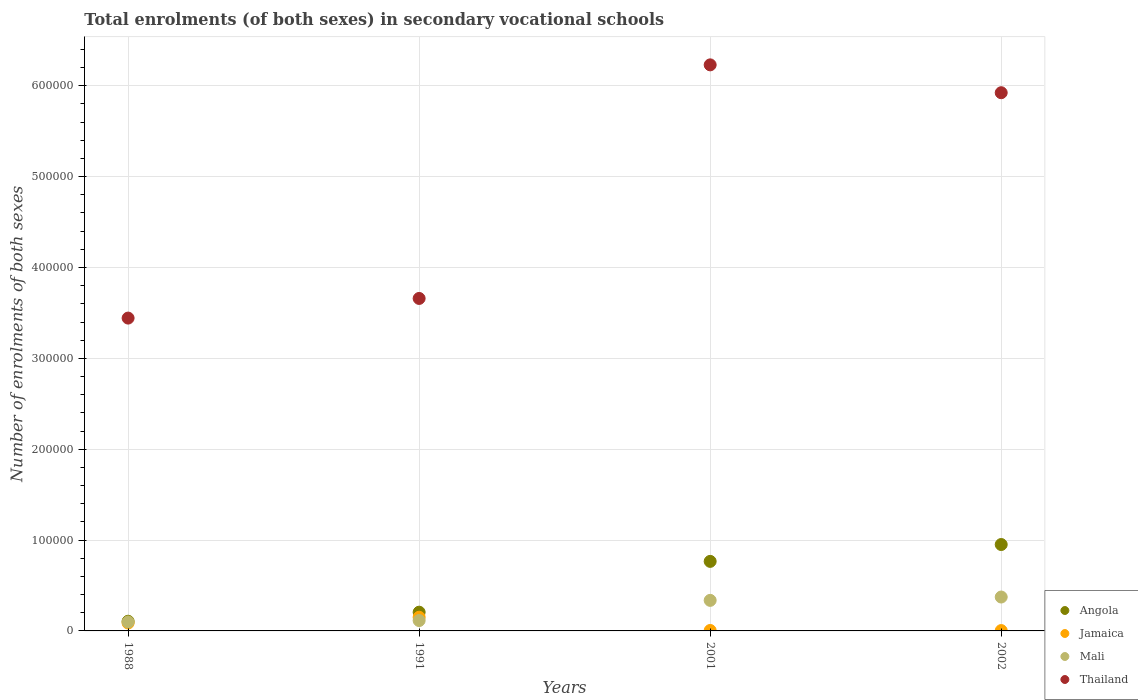How many different coloured dotlines are there?
Make the answer very short. 4. Is the number of dotlines equal to the number of legend labels?
Your response must be concise. Yes. What is the number of enrolments in secondary schools in Jamaica in 2002?
Your answer should be compact. 382. Across all years, what is the maximum number of enrolments in secondary schools in Mali?
Ensure brevity in your answer.  3.73e+04. Across all years, what is the minimum number of enrolments in secondary schools in Angola?
Give a very brief answer. 1.07e+04. In which year was the number of enrolments in secondary schools in Angola minimum?
Provide a succinct answer. 1988. What is the total number of enrolments in secondary schools in Jamaica in the graph?
Your response must be concise. 2.47e+04. What is the difference between the number of enrolments in secondary schools in Angola in 1988 and that in 2002?
Make the answer very short. -8.44e+04. What is the difference between the number of enrolments in secondary schools in Thailand in 1988 and the number of enrolments in secondary schools in Jamaica in 2001?
Give a very brief answer. 3.44e+05. What is the average number of enrolments in secondary schools in Mali per year?
Offer a very short reply. 2.30e+04. In the year 2001, what is the difference between the number of enrolments in secondary schools in Angola and number of enrolments in secondary schools in Thailand?
Keep it short and to the point. -5.46e+05. In how many years, is the number of enrolments in secondary schools in Angola greater than 120000?
Your answer should be very brief. 0. What is the ratio of the number of enrolments in secondary schools in Angola in 2001 to that in 2002?
Give a very brief answer. 0.8. What is the difference between the highest and the second highest number of enrolments in secondary schools in Thailand?
Give a very brief answer. 3.07e+04. What is the difference between the highest and the lowest number of enrolments in secondary schools in Thailand?
Give a very brief answer. 2.79e+05. Is the sum of the number of enrolments in secondary schools in Angola in 1991 and 2002 greater than the maximum number of enrolments in secondary schools in Mali across all years?
Your answer should be compact. Yes. Is it the case that in every year, the sum of the number of enrolments in secondary schools in Mali and number of enrolments in secondary schools in Angola  is greater than the sum of number of enrolments in secondary schools in Thailand and number of enrolments in secondary schools in Jamaica?
Your answer should be compact. No. Is the number of enrolments in secondary schools in Jamaica strictly less than the number of enrolments in secondary schools in Mali over the years?
Provide a succinct answer. No. How many dotlines are there?
Offer a terse response. 4. Are the values on the major ticks of Y-axis written in scientific E-notation?
Ensure brevity in your answer.  No. Does the graph contain any zero values?
Ensure brevity in your answer.  No. Does the graph contain grids?
Provide a succinct answer. Yes. How many legend labels are there?
Your answer should be compact. 4. How are the legend labels stacked?
Offer a very short reply. Vertical. What is the title of the graph?
Keep it short and to the point. Total enrolments (of both sexes) in secondary vocational schools. What is the label or title of the Y-axis?
Make the answer very short. Number of enrolments of both sexes. What is the Number of enrolments of both sexes of Angola in 1988?
Your response must be concise. 1.07e+04. What is the Number of enrolments of both sexes of Jamaica in 1988?
Keep it short and to the point. 8717. What is the Number of enrolments of both sexes in Mali in 1988?
Your response must be concise. 9813. What is the Number of enrolments of both sexes of Thailand in 1988?
Keep it short and to the point. 3.44e+05. What is the Number of enrolments of both sexes in Angola in 1991?
Ensure brevity in your answer.  2.06e+04. What is the Number of enrolments of both sexes of Jamaica in 1991?
Ensure brevity in your answer.  1.51e+04. What is the Number of enrolments of both sexes of Mali in 1991?
Provide a succinct answer. 1.14e+04. What is the Number of enrolments of both sexes of Thailand in 1991?
Make the answer very short. 3.66e+05. What is the Number of enrolments of both sexes in Angola in 2001?
Keep it short and to the point. 7.65e+04. What is the Number of enrolments of both sexes in Jamaica in 2001?
Ensure brevity in your answer.  498. What is the Number of enrolments of both sexes in Mali in 2001?
Offer a very short reply. 3.36e+04. What is the Number of enrolments of both sexes of Thailand in 2001?
Your answer should be very brief. 6.23e+05. What is the Number of enrolments of both sexes in Angola in 2002?
Offer a terse response. 9.51e+04. What is the Number of enrolments of both sexes of Jamaica in 2002?
Ensure brevity in your answer.  382. What is the Number of enrolments of both sexes in Mali in 2002?
Provide a succinct answer. 3.73e+04. What is the Number of enrolments of both sexes in Thailand in 2002?
Offer a terse response. 5.92e+05. Across all years, what is the maximum Number of enrolments of both sexes in Angola?
Offer a terse response. 9.51e+04. Across all years, what is the maximum Number of enrolments of both sexes in Jamaica?
Ensure brevity in your answer.  1.51e+04. Across all years, what is the maximum Number of enrolments of both sexes in Mali?
Provide a succinct answer. 3.73e+04. Across all years, what is the maximum Number of enrolments of both sexes of Thailand?
Offer a terse response. 6.23e+05. Across all years, what is the minimum Number of enrolments of both sexes of Angola?
Offer a very short reply. 1.07e+04. Across all years, what is the minimum Number of enrolments of both sexes in Jamaica?
Your response must be concise. 382. Across all years, what is the minimum Number of enrolments of both sexes in Mali?
Give a very brief answer. 9813. Across all years, what is the minimum Number of enrolments of both sexes in Thailand?
Keep it short and to the point. 3.44e+05. What is the total Number of enrolments of both sexes of Angola in the graph?
Offer a terse response. 2.03e+05. What is the total Number of enrolments of both sexes in Jamaica in the graph?
Provide a short and direct response. 2.47e+04. What is the total Number of enrolments of both sexes of Mali in the graph?
Provide a short and direct response. 9.22e+04. What is the total Number of enrolments of both sexes of Thailand in the graph?
Your response must be concise. 1.93e+06. What is the difference between the Number of enrolments of both sexes of Angola in 1988 and that in 1991?
Your answer should be compact. -9962. What is the difference between the Number of enrolments of both sexes in Jamaica in 1988 and that in 1991?
Keep it short and to the point. -6353. What is the difference between the Number of enrolments of both sexes in Mali in 1988 and that in 1991?
Your response must be concise. -1619. What is the difference between the Number of enrolments of both sexes in Thailand in 1988 and that in 1991?
Make the answer very short. -2.16e+04. What is the difference between the Number of enrolments of both sexes in Angola in 1988 and that in 2001?
Provide a short and direct response. -6.59e+04. What is the difference between the Number of enrolments of both sexes in Jamaica in 1988 and that in 2001?
Make the answer very short. 8219. What is the difference between the Number of enrolments of both sexes in Mali in 1988 and that in 2001?
Your answer should be very brief. -2.38e+04. What is the difference between the Number of enrolments of both sexes in Thailand in 1988 and that in 2001?
Provide a succinct answer. -2.79e+05. What is the difference between the Number of enrolments of both sexes in Angola in 1988 and that in 2002?
Ensure brevity in your answer.  -8.44e+04. What is the difference between the Number of enrolments of both sexes of Jamaica in 1988 and that in 2002?
Give a very brief answer. 8335. What is the difference between the Number of enrolments of both sexes in Mali in 1988 and that in 2002?
Offer a very short reply. -2.75e+04. What is the difference between the Number of enrolments of both sexes of Thailand in 1988 and that in 2002?
Keep it short and to the point. -2.48e+05. What is the difference between the Number of enrolments of both sexes of Angola in 1991 and that in 2001?
Provide a short and direct response. -5.59e+04. What is the difference between the Number of enrolments of both sexes in Jamaica in 1991 and that in 2001?
Ensure brevity in your answer.  1.46e+04. What is the difference between the Number of enrolments of both sexes in Mali in 1991 and that in 2001?
Ensure brevity in your answer.  -2.22e+04. What is the difference between the Number of enrolments of both sexes of Thailand in 1991 and that in 2001?
Provide a succinct answer. -2.57e+05. What is the difference between the Number of enrolments of both sexes of Angola in 1991 and that in 2002?
Your response must be concise. -7.45e+04. What is the difference between the Number of enrolments of both sexes of Jamaica in 1991 and that in 2002?
Make the answer very short. 1.47e+04. What is the difference between the Number of enrolments of both sexes of Mali in 1991 and that in 2002?
Offer a very short reply. -2.59e+04. What is the difference between the Number of enrolments of both sexes of Thailand in 1991 and that in 2002?
Offer a very short reply. -2.26e+05. What is the difference between the Number of enrolments of both sexes in Angola in 2001 and that in 2002?
Provide a succinct answer. -1.86e+04. What is the difference between the Number of enrolments of both sexes in Jamaica in 2001 and that in 2002?
Offer a terse response. 116. What is the difference between the Number of enrolments of both sexes in Mali in 2001 and that in 2002?
Your answer should be compact. -3677. What is the difference between the Number of enrolments of both sexes in Thailand in 2001 and that in 2002?
Offer a very short reply. 3.07e+04. What is the difference between the Number of enrolments of both sexes in Angola in 1988 and the Number of enrolments of both sexes in Jamaica in 1991?
Provide a short and direct response. -4408. What is the difference between the Number of enrolments of both sexes of Angola in 1988 and the Number of enrolments of both sexes of Mali in 1991?
Keep it short and to the point. -770. What is the difference between the Number of enrolments of both sexes of Angola in 1988 and the Number of enrolments of both sexes of Thailand in 1991?
Offer a very short reply. -3.55e+05. What is the difference between the Number of enrolments of both sexes of Jamaica in 1988 and the Number of enrolments of both sexes of Mali in 1991?
Offer a very short reply. -2715. What is the difference between the Number of enrolments of both sexes in Jamaica in 1988 and the Number of enrolments of both sexes in Thailand in 1991?
Ensure brevity in your answer.  -3.57e+05. What is the difference between the Number of enrolments of both sexes of Mali in 1988 and the Number of enrolments of both sexes of Thailand in 1991?
Your answer should be very brief. -3.56e+05. What is the difference between the Number of enrolments of both sexes in Angola in 1988 and the Number of enrolments of both sexes in Jamaica in 2001?
Your answer should be compact. 1.02e+04. What is the difference between the Number of enrolments of both sexes in Angola in 1988 and the Number of enrolments of both sexes in Mali in 2001?
Ensure brevity in your answer.  -2.30e+04. What is the difference between the Number of enrolments of both sexes in Angola in 1988 and the Number of enrolments of both sexes in Thailand in 2001?
Offer a terse response. -6.12e+05. What is the difference between the Number of enrolments of both sexes of Jamaica in 1988 and the Number of enrolments of both sexes of Mali in 2001?
Your answer should be very brief. -2.49e+04. What is the difference between the Number of enrolments of both sexes in Jamaica in 1988 and the Number of enrolments of both sexes in Thailand in 2001?
Provide a short and direct response. -6.14e+05. What is the difference between the Number of enrolments of both sexes in Mali in 1988 and the Number of enrolments of both sexes in Thailand in 2001?
Give a very brief answer. -6.13e+05. What is the difference between the Number of enrolments of both sexes of Angola in 1988 and the Number of enrolments of both sexes of Jamaica in 2002?
Your answer should be very brief. 1.03e+04. What is the difference between the Number of enrolments of both sexes in Angola in 1988 and the Number of enrolments of both sexes in Mali in 2002?
Give a very brief answer. -2.66e+04. What is the difference between the Number of enrolments of both sexes in Angola in 1988 and the Number of enrolments of both sexes in Thailand in 2002?
Your answer should be compact. -5.82e+05. What is the difference between the Number of enrolments of both sexes in Jamaica in 1988 and the Number of enrolments of both sexes in Mali in 2002?
Your answer should be compact. -2.86e+04. What is the difference between the Number of enrolments of both sexes in Jamaica in 1988 and the Number of enrolments of both sexes in Thailand in 2002?
Your response must be concise. -5.84e+05. What is the difference between the Number of enrolments of both sexes in Mali in 1988 and the Number of enrolments of both sexes in Thailand in 2002?
Give a very brief answer. -5.83e+05. What is the difference between the Number of enrolments of both sexes in Angola in 1991 and the Number of enrolments of both sexes in Jamaica in 2001?
Provide a short and direct response. 2.01e+04. What is the difference between the Number of enrolments of both sexes in Angola in 1991 and the Number of enrolments of both sexes in Mali in 2001?
Your response must be concise. -1.30e+04. What is the difference between the Number of enrolments of both sexes of Angola in 1991 and the Number of enrolments of both sexes of Thailand in 2001?
Make the answer very short. -6.02e+05. What is the difference between the Number of enrolments of both sexes in Jamaica in 1991 and the Number of enrolments of both sexes in Mali in 2001?
Ensure brevity in your answer.  -1.86e+04. What is the difference between the Number of enrolments of both sexes of Jamaica in 1991 and the Number of enrolments of both sexes of Thailand in 2001?
Offer a very short reply. -6.08e+05. What is the difference between the Number of enrolments of both sexes in Mali in 1991 and the Number of enrolments of both sexes in Thailand in 2001?
Provide a short and direct response. -6.12e+05. What is the difference between the Number of enrolments of both sexes in Angola in 1991 and the Number of enrolments of both sexes in Jamaica in 2002?
Offer a terse response. 2.02e+04. What is the difference between the Number of enrolments of both sexes in Angola in 1991 and the Number of enrolments of both sexes in Mali in 2002?
Provide a succinct answer. -1.67e+04. What is the difference between the Number of enrolments of both sexes of Angola in 1991 and the Number of enrolments of both sexes of Thailand in 2002?
Make the answer very short. -5.72e+05. What is the difference between the Number of enrolments of both sexes in Jamaica in 1991 and the Number of enrolments of both sexes in Mali in 2002?
Keep it short and to the point. -2.22e+04. What is the difference between the Number of enrolments of both sexes in Jamaica in 1991 and the Number of enrolments of both sexes in Thailand in 2002?
Your response must be concise. -5.77e+05. What is the difference between the Number of enrolments of both sexes of Mali in 1991 and the Number of enrolments of both sexes of Thailand in 2002?
Provide a short and direct response. -5.81e+05. What is the difference between the Number of enrolments of both sexes of Angola in 2001 and the Number of enrolments of both sexes of Jamaica in 2002?
Keep it short and to the point. 7.62e+04. What is the difference between the Number of enrolments of both sexes of Angola in 2001 and the Number of enrolments of both sexes of Mali in 2002?
Your answer should be compact. 3.92e+04. What is the difference between the Number of enrolments of both sexes of Angola in 2001 and the Number of enrolments of both sexes of Thailand in 2002?
Keep it short and to the point. -5.16e+05. What is the difference between the Number of enrolments of both sexes in Jamaica in 2001 and the Number of enrolments of both sexes in Mali in 2002?
Ensure brevity in your answer.  -3.68e+04. What is the difference between the Number of enrolments of both sexes in Jamaica in 2001 and the Number of enrolments of both sexes in Thailand in 2002?
Ensure brevity in your answer.  -5.92e+05. What is the difference between the Number of enrolments of both sexes in Mali in 2001 and the Number of enrolments of both sexes in Thailand in 2002?
Offer a very short reply. -5.59e+05. What is the average Number of enrolments of both sexes of Angola per year?
Your answer should be compact. 5.07e+04. What is the average Number of enrolments of both sexes in Jamaica per year?
Ensure brevity in your answer.  6166.75. What is the average Number of enrolments of both sexes of Mali per year?
Your answer should be compact. 2.30e+04. What is the average Number of enrolments of both sexes of Thailand per year?
Your answer should be compact. 4.81e+05. In the year 1988, what is the difference between the Number of enrolments of both sexes in Angola and Number of enrolments of both sexes in Jamaica?
Make the answer very short. 1945. In the year 1988, what is the difference between the Number of enrolments of both sexes in Angola and Number of enrolments of both sexes in Mali?
Ensure brevity in your answer.  849. In the year 1988, what is the difference between the Number of enrolments of both sexes of Angola and Number of enrolments of both sexes of Thailand?
Offer a terse response. -3.34e+05. In the year 1988, what is the difference between the Number of enrolments of both sexes in Jamaica and Number of enrolments of both sexes in Mali?
Your response must be concise. -1096. In the year 1988, what is the difference between the Number of enrolments of both sexes in Jamaica and Number of enrolments of both sexes in Thailand?
Your response must be concise. -3.36e+05. In the year 1988, what is the difference between the Number of enrolments of both sexes in Mali and Number of enrolments of both sexes in Thailand?
Give a very brief answer. -3.35e+05. In the year 1991, what is the difference between the Number of enrolments of both sexes of Angola and Number of enrolments of both sexes of Jamaica?
Offer a very short reply. 5554. In the year 1991, what is the difference between the Number of enrolments of both sexes in Angola and Number of enrolments of both sexes in Mali?
Make the answer very short. 9192. In the year 1991, what is the difference between the Number of enrolments of both sexes of Angola and Number of enrolments of both sexes of Thailand?
Give a very brief answer. -3.45e+05. In the year 1991, what is the difference between the Number of enrolments of both sexes in Jamaica and Number of enrolments of both sexes in Mali?
Provide a succinct answer. 3638. In the year 1991, what is the difference between the Number of enrolments of both sexes of Jamaica and Number of enrolments of both sexes of Thailand?
Your answer should be very brief. -3.51e+05. In the year 1991, what is the difference between the Number of enrolments of both sexes of Mali and Number of enrolments of both sexes of Thailand?
Provide a short and direct response. -3.55e+05. In the year 2001, what is the difference between the Number of enrolments of both sexes in Angola and Number of enrolments of both sexes in Jamaica?
Give a very brief answer. 7.60e+04. In the year 2001, what is the difference between the Number of enrolments of both sexes of Angola and Number of enrolments of both sexes of Mali?
Provide a short and direct response. 4.29e+04. In the year 2001, what is the difference between the Number of enrolments of both sexes of Angola and Number of enrolments of both sexes of Thailand?
Make the answer very short. -5.46e+05. In the year 2001, what is the difference between the Number of enrolments of both sexes of Jamaica and Number of enrolments of both sexes of Mali?
Keep it short and to the point. -3.31e+04. In the year 2001, what is the difference between the Number of enrolments of both sexes in Jamaica and Number of enrolments of both sexes in Thailand?
Give a very brief answer. -6.23e+05. In the year 2001, what is the difference between the Number of enrolments of both sexes of Mali and Number of enrolments of both sexes of Thailand?
Offer a terse response. -5.89e+05. In the year 2002, what is the difference between the Number of enrolments of both sexes in Angola and Number of enrolments of both sexes in Jamaica?
Ensure brevity in your answer.  9.47e+04. In the year 2002, what is the difference between the Number of enrolments of both sexes in Angola and Number of enrolments of both sexes in Mali?
Offer a very short reply. 5.78e+04. In the year 2002, what is the difference between the Number of enrolments of both sexes of Angola and Number of enrolments of both sexes of Thailand?
Offer a terse response. -4.97e+05. In the year 2002, what is the difference between the Number of enrolments of both sexes of Jamaica and Number of enrolments of both sexes of Mali?
Offer a very short reply. -3.69e+04. In the year 2002, what is the difference between the Number of enrolments of both sexes in Jamaica and Number of enrolments of both sexes in Thailand?
Your response must be concise. -5.92e+05. In the year 2002, what is the difference between the Number of enrolments of both sexes of Mali and Number of enrolments of both sexes of Thailand?
Your answer should be very brief. -5.55e+05. What is the ratio of the Number of enrolments of both sexes of Angola in 1988 to that in 1991?
Your answer should be very brief. 0.52. What is the ratio of the Number of enrolments of both sexes of Jamaica in 1988 to that in 1991?
Make the answer very short. 0.58. What is the ratio of the Number of enrolments of both sexes of Mali in 1988 to that in 1991?
Your answer should be compact. 0.86. What is the ratio of the Number of enrolments of both sexes in Thailand in 1988 to that in 1991?
Ensure brevity in your answer.  0.94. What is the ratio of the Number of enrolments of both sexes in Angola in 1988 to that in 2001?
Your answer should be very brief. 0.14. What is the ratio of the Number of enrolments of both sexes in Jamaica in 1988 to that in 2001?
Keep it short and to the point. 17.5. What is the ratio of the Number of enrolments of both sexes of Mali in 1988 to that in 2001?
Make the answer very short. 0.29. What is the ratio of the Number of enrolments of both sexes in Thailand in 1988 to that in 2001?
Make the answer very short. 0.55. What is the ratio of the Number of enrolments of both sexes of Angola in 1988 to that in 2002?
Provide a succinct answer. 0.11. What is the ratio of the Number of enrolments of both sexes of Jamaica in 1988 to that in 2002?
Keep it short and to the point. 22.82. What is the ratio of the Number of enrolments of both sexes of Mali in 1988 to that in 2002?
Your response must be concise. 0.26. What is the ratio of the Number of enrolments of both sexes of Thailand in 1988 to that in 2002?
Your response must be concise. 0.58. What is the ratio of the Number of enrolments of both sexes in Angola in 1991 to that in 2001?
Your answer should be very brief. 0.27. What is the ratio of the Number of enrolments of both sexes of Jamaica in 1991 to that in 2001?
Provide a short and direct response. 30.26. What is the ratio of the Number of enrolments of both sexes of Mali in 1991 to that in 2001?
Offer a very short reply. 0.34. What is the ratio of the Number of enrolments of both sexes in Thailand in 1991 to that in 2001?
Offer a terse response. 0.59. What is the ratio of the Number of enrolments of both sexes of Angola in 1991 to that in 2002?
Keep it short and to the point. 0.22. What is the ratio of the Number of enrolments of both sexes in Jamaica in 1991 to that in 2002?
Ensure brevity in your answer.  39.45. What is the ratio of the Number of enrolments of both sexes of Mali in 1991 to that in 2002?
Provide a succinct answer. 0.31. What is the ratio of the Number of enrolments of both sexes in Thailand in 1991 to that in 2002?
Offer a very short reply. 0.62. What is the ratio of the Number of enrolments of both sexes in Angola in 2001 to that in 2002?
Offer a terse response. 0.8. What is the ratio of the Number of enrolments of both sexes of Jamaica in 2001 to that in 2002?
Your answer should be very brief. 1.3. What is the ratio of the Number of enrolments of both sexes in Mali in 2001 to that in 2002?
Make the answer very short. 0.9. What is the ratio of the Number of enrolments of both sexes of Thailand in 2001 to that in 2002?
Make the answer very short. 1.05. What is the difference between the highest and the second highest Number of enrolments of both sexes of Angola?
Offer a very short reply. 1.86e+04. What is the difference between the highest and the second highest Number of enrolments of both sexes in Jamaica?
Keep it short and to the point. 6353. What is the difference between the highest and the second highest Number of enrolments of both sexes of Mali?
Offer a terse response. 3677. What is the difference between the highest and the second highest Number of enrolments of both sexes in Thailand?
Give a very brief answer. 3.07e+04. What is the difference between the highest and the lowest Number of enrolments of both sexes in Angola?
Provide a succinct answer. 8.44e+04. What is the difference between the highest and the lowest Number of enrolments of both sexes of Jamaica?
Ensure brevity in your answer.  1.47e+04. What is the difference between the highest and the lowest Number of enrolments of both sexes of Mali?
Provide a short and direct response. 2.75e+04. What is the difference between the highest and the lowest Number of enrolments of both sexes in Thailand?
Keep it short and to the point. 2.79e+05. 